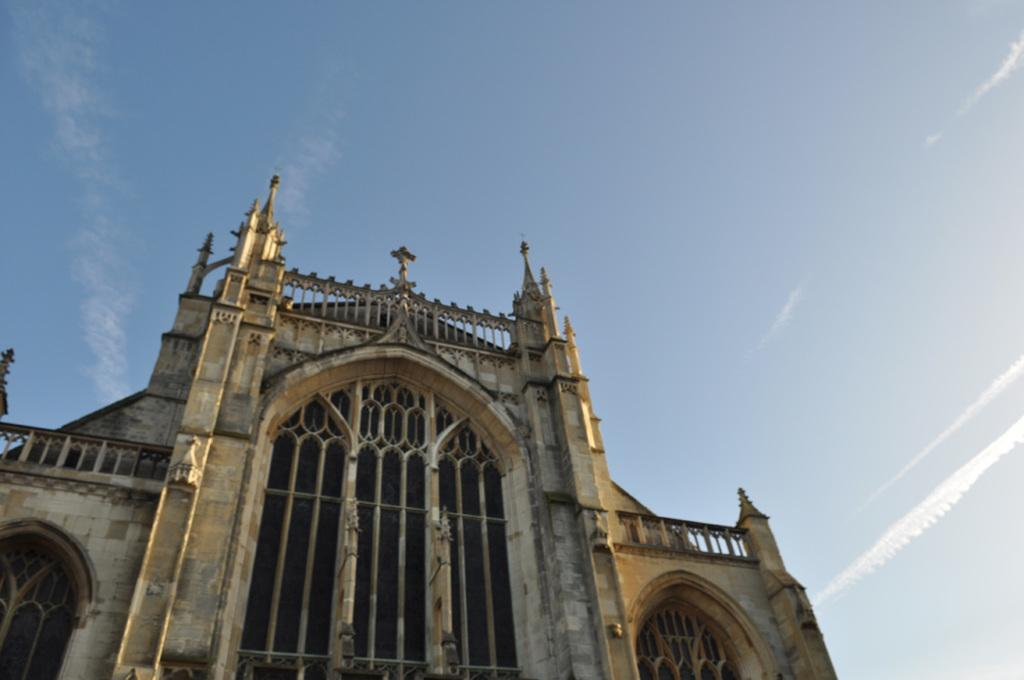What type of building is shown in the image? The image depicts a church. What architectural features can be seen on the church? The church has windows and doors, as well as pillars. What is visible in the background of the image? The sky is visible in the image. What type of cream is being used to destroy the church in the image? There is no cream or destruction present in the image; it depicts a church with its architectural features. What type of discussion is taking place in front of the church in the image? There is no discussion or people present in the image; it only shows the church and its features. 